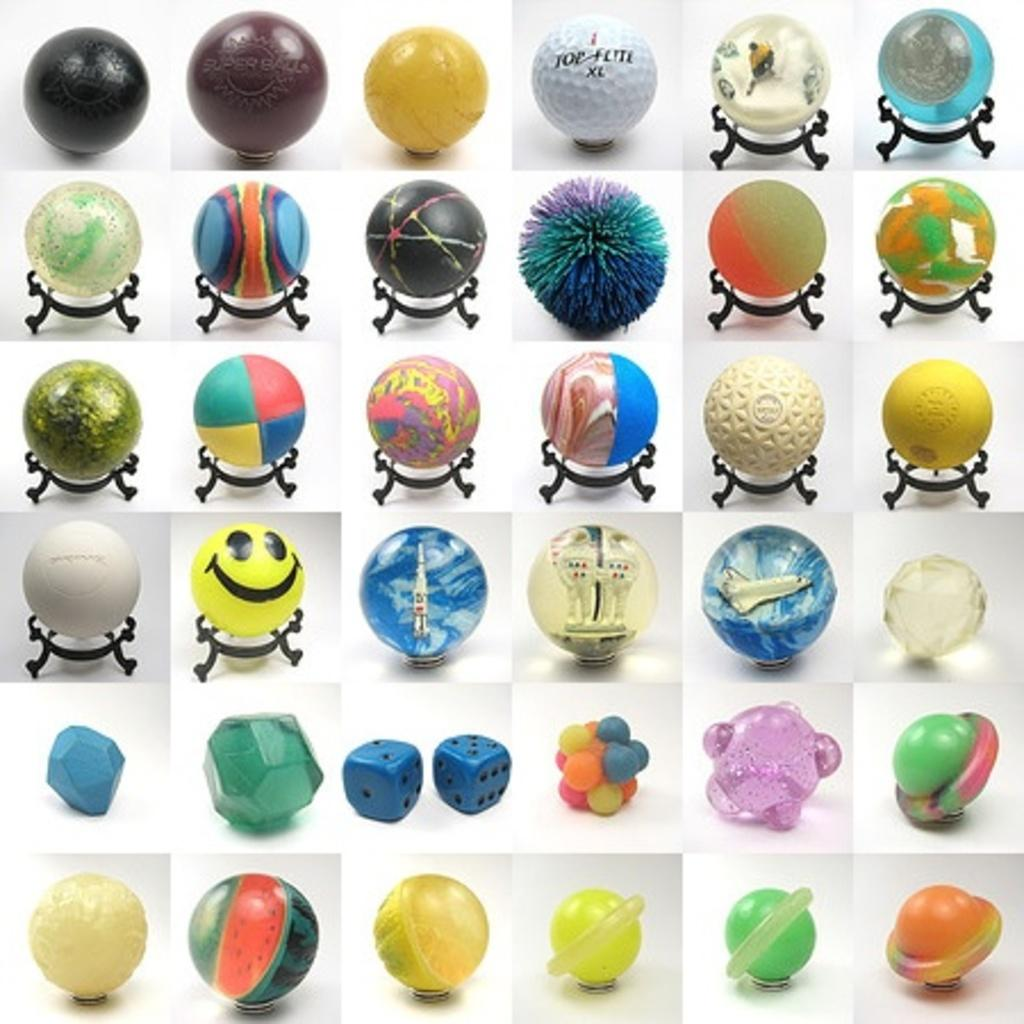What type of objects can be seen in the image? There are circular shape colorful objects in the image. Can you describe the setting of the image? The image is set in a college environment. What cast member from a popular TV show is seen in the image? There are no cast members from a popular TV show present in the image. What arm position does the person in the image have? There is no person present in the image, only circular shape colorful objects. 